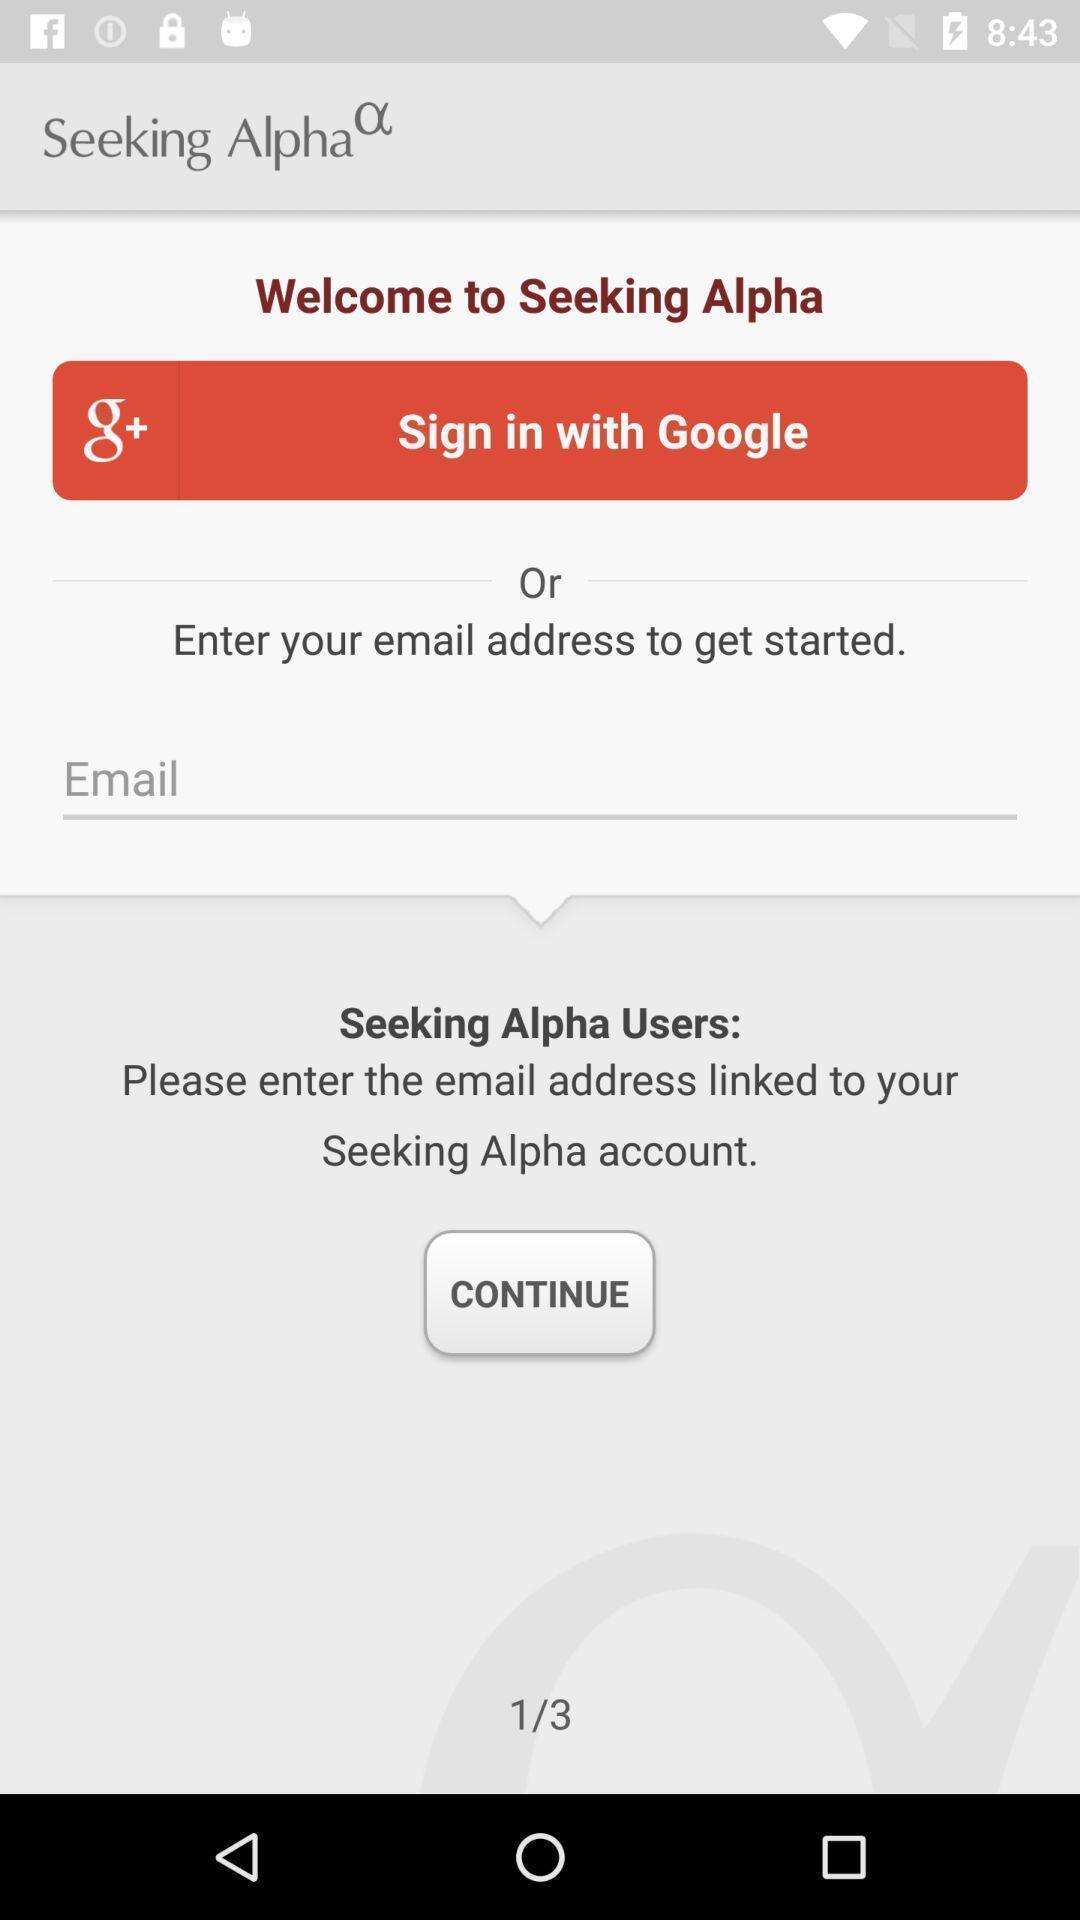What is the overall content of this screenshot? Sign in page for a stocks tracking app. 